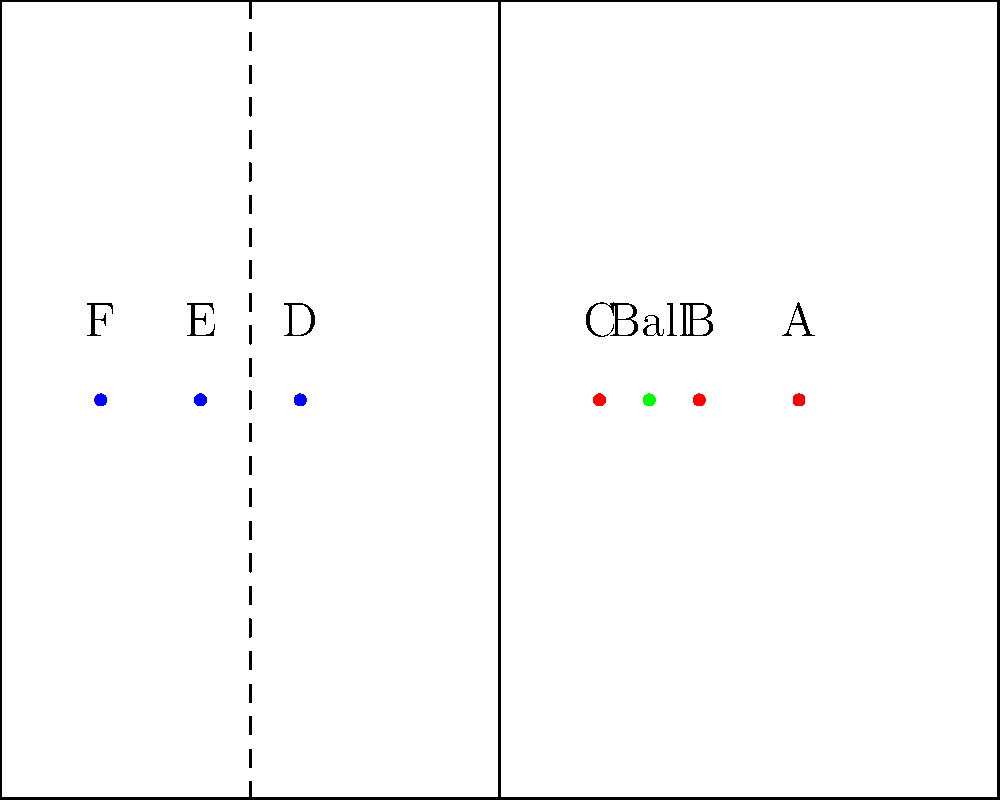In this soccer field diagram, which attacking player (red) is in an offside position when the ball is passed forward by their teammate? To determine if a player is in an offside position, we need to follow these steps:

1. Identify the position of the ball: The ball is between players B and C.

2. Identify the second-last defender: Player E is the second-last defender from the attacking team's perspective.

3. Establish the offside line: The offside line is drawn through player E, represented by the dashed line.

4. Compare attacking players' positions to the offside line:
   - Player A is ahead of the offside line
   - Player B is behind the offside line
   - Player C is behind the offside line

5. Determine offside position: Only player A is ahead of both the ball and the second-last defender (player E) when the ball is played forward.

Therefore, player A is in an offside position when the ball is passed forward by their teammate.
Answer: Player A 